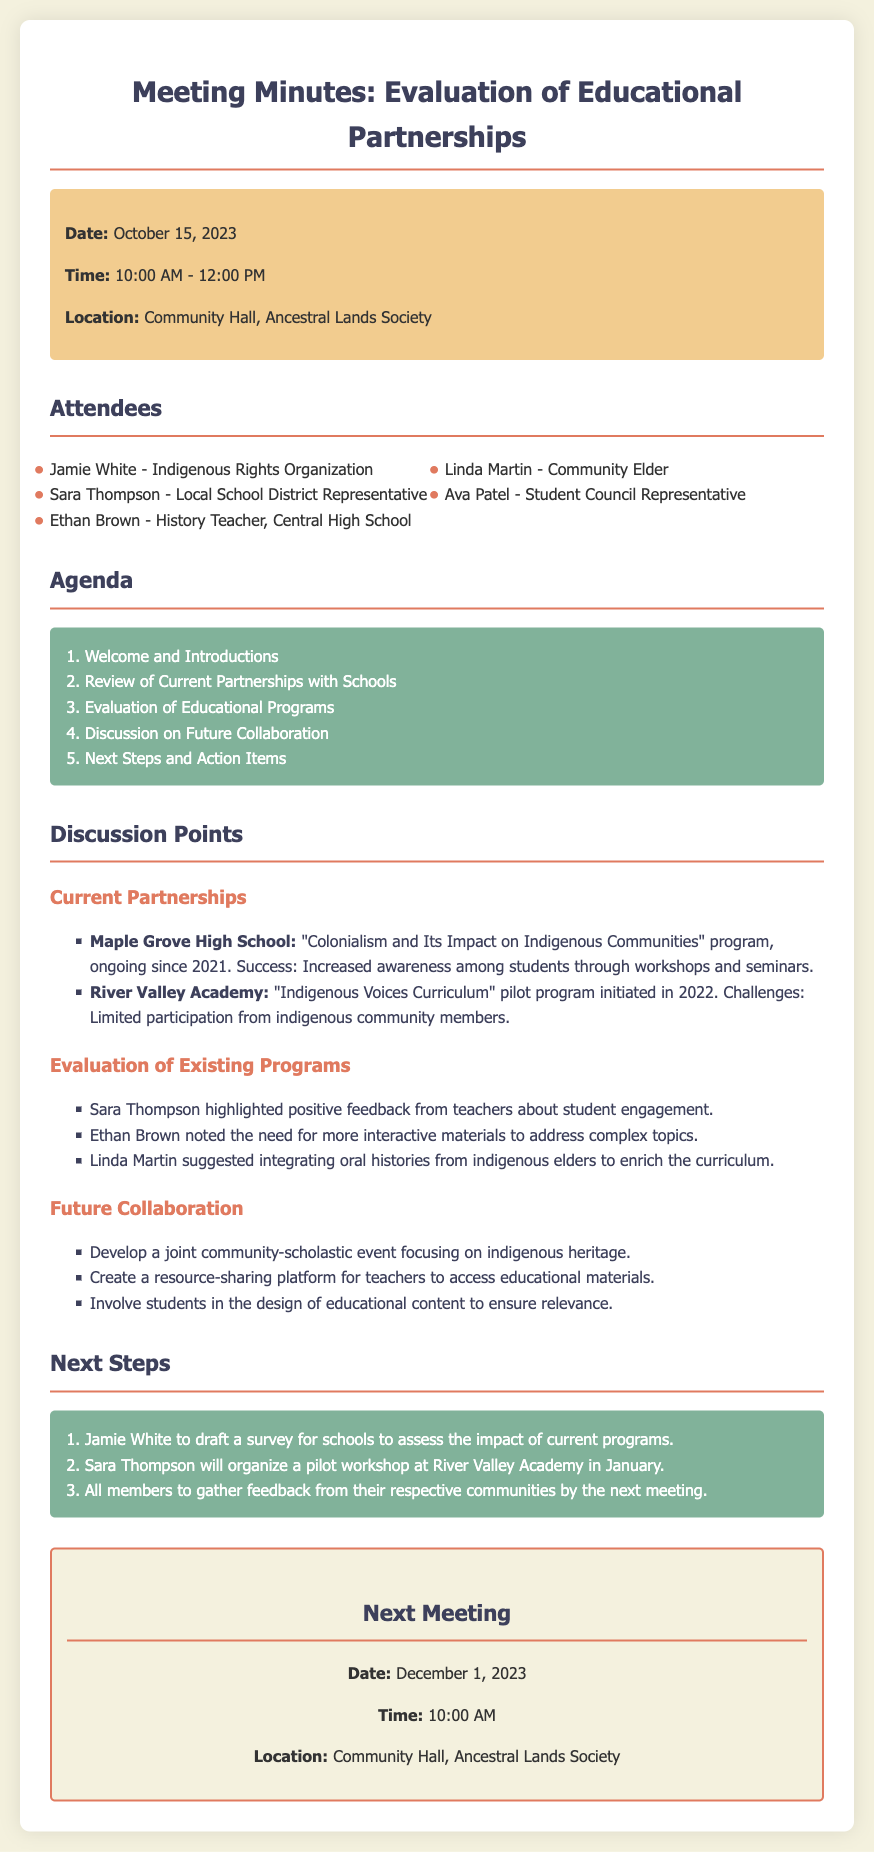What is the date of the meeting? The date of the meeting is explicitly stated in the document.
Answer: October 15, 2023 Who represents the Indigenous Rights Organization? This refers to the attendee mentioned in the document with that affiliation.
Answer: Jamie White What program is ongoing at Maple Grove High School? This program is specifically noted in the discussion points under current partnerships.
Answer: "Colonialism and Its Impact on Indigenous Communities" What feedback did Sara Thompson mention about the programs? The feedback provided is highlighted in the evaluation of existing programs section.
Answer: Positive feedback from teachers What is one challenge mentioned about the River Valley Academy program? The specific challenge is noted in the discussion about current partnerships with schools.
Answer: Limited participation from indigenous community members How many action items are listed in the next steps? The action items can be counted in the next steps section of the document.
Answer: Three When is the next meeting scheduled? The next meeting date is provided at the end of the document.
Answer: December 1, 2023 Who suggested integrating oral histories into the curriculum? This individual is mentioned in the evaluation discussion.
Answer: Linda Martin What will Jamie White draft after the meeting? This task is specified in the next steps section of the notes.
Answer: A survey for schools 